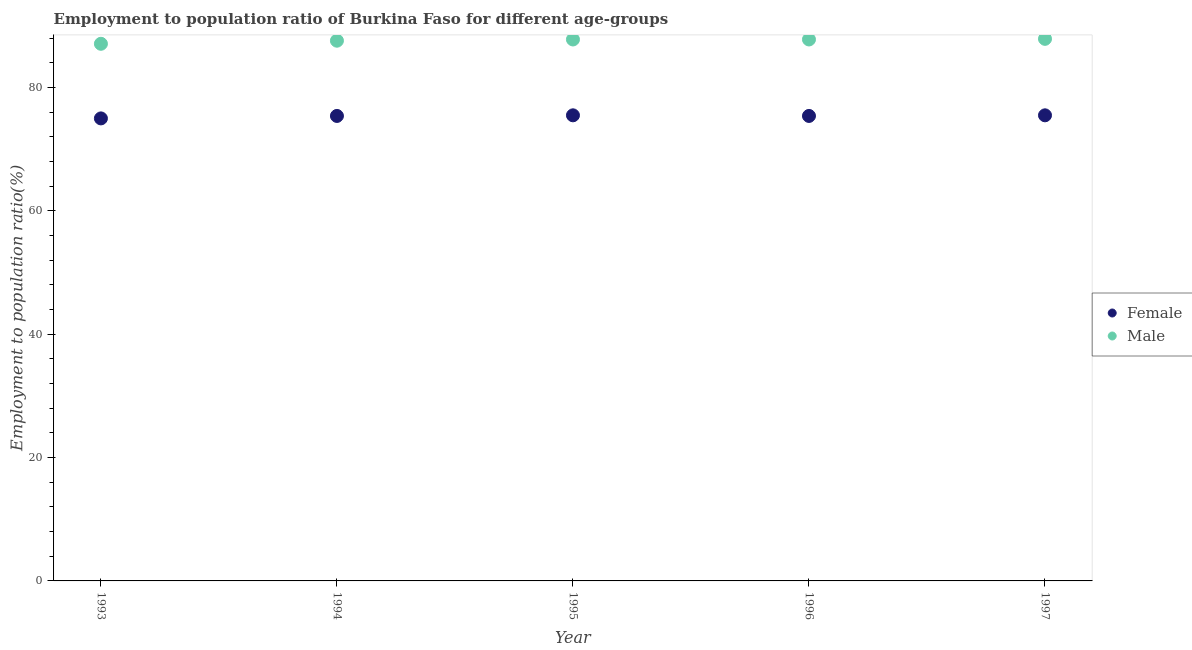Is the number of dotlines equal to the number of legend labels?
Your response must be concise. Yes. What is the employment to population ratio(male) in 1994?
Your answer should be compact. 87.6. Across all years, what is the maximum employment to population ratio(male)?
Your answer should be compact. 87.9. Across all years, what is the minimum employment to population ratio(female)?
Provide a succinct answer. 75. What is the total employment to population ratio(male) in the graph?
Keep it short and to the point. 438.2. What is the difference between the employment to population ratio(male) in 1994 and the employment to population ratio(female) in 1995?
Your answer should be very brief. 12.1. What is the average employment to population ratio(male) per year?
Keep it short and to the point. 87.64. In the year 1993, what is the difference between the employment to population ratio(female) and employment to population ratio(male)?
Keep it short and to the point. -12.1. What is the ratio of the employment to population ratio(female) in 1996 to that in 1997?
Provide a succinct answer. 1. What is the difference between the highest and the second highest employment to population ratio(female)?
Provide a succinct answer. 0. What is the difference between the highest and the lowest employment to population ratio(male)?
Provide a succinct answer. 0.8. In how many years, is the employment to population ratio(female) greater than the average employment to population ratio(female) taken over all years?
Ensure brevity in your answer.  4. Is the sum of the employment to population ratio(female) in 1996 and 1997 greater than the maximum employment to population ratio(male) across all years?
Ensure brevity in your answer.  Yes. Does the employment to population ratio(female) monotonically increase over the years?
Make the answer very short. No. What is the difference between two consecutive major ticks on the Y-axis?
Make the answer very short. 20. Are the values on the major ticks of Y-axis written in scientific E-notation?
Provide a short and direct response. No. Does the graph contain grids?
Make the answer very short. No. Where does the legend appear in the graph?
Your answer should be very brief. Center right. How are the legend labels stacked?
Ensure brevity in your answer.  Vertical. What is the title of the graph?
Offer a very short reply. Employment to population ratio of Burkina Faso for different age-groups. What is the label or title of the Y-axis?
Provide a short and direct response. Employment to population ratio(%). What is the Employment to population ratio(%) in Female in 1993?
Give a very brief answer. 75. What is the Employment to population ratio(%) in Male in 1993?
Your answer should be very brief. 87.1. What is the Employment to population ratio(%) in Female in 1994?
Provide a succinct answer. 75.4. What is the Employment to population ratio(%) in Male in 1994?
Offer a very short reply. 87.6. What is the Employment to population ratio(%) in Female in 1995?
Give a very brief answer. 75.5. What is the Employment to population ratio(%) in Male in 1995?
Make the answer very short. 87.8. What is the Employment to population ratio(%) in Female in 1996?
Give a very brief answer. 75.4. What is the Employment to population ratio(%) of Male in 1996?
Offer a very short reply. 87.8. What is the Employment to population ratio(%) of Female in 1997?
Offer a very short reply. 75.5. What is the Employment to population ratio(%) of Male in 1997?
Ensure brevity in your answer.  87.9. Across all years, what is the maximum Employment to population ratio(%) of Female?
Give a very brief answer. 75.5. Across all years, what is the maximum Employment to population ratio(%) in Male?
Your answer should be very brief. 87.9. Across all years, what is the minimum Employment to population ratio(%) of Female?
Your answer should be very brief. 75. Across all years, what is the minimum Employment to population ratio(%) of Male?
Your response must be concise. 87.1. What is the total Employment to population ratio(%) of Female in the graph?
Your answer should be compact. 376.8. What is the total Employment to population ratio(%) of Male in the graph?
Offer a very short reply. 438.2. What is the difference between the Employment to population ratio(%) of Male in 1993 and that in 1994?
Offer a terse response. -0.5. What is the difference between the Employment to population ratio(%) in Female in 1993 and that in 1996?
Your answer should be compact. -0.4. What is the difference between the Employment to population ratio(%) in Female in 1994 and that in 1995?
Your answer should be compact. -0.1. What is the difference between the Employment to population ratio(%) in Male in 1994 and that in 1995?
Provide a succinct answer. -0.2. What is the difference between the Employment to population ratio(%) in Female in 1994 and that in 1996?
Provide a short and direct response. 0. What is the difference between the Employment to population ratio(%) in Male in 1994 and that in 1997?
Your response must be concise. -0.3. What is the difference between the Employment to population ratio(%) in Female in 1995 and that in 1997?
Keep it short and to the point. 0. What is the difference between the Employment to population ratio(%) of Female in 1996 and that in 1997?
Give a very brief answer. -0.1. What is the difference between the Employment to population ratio(%) in Female in 1993 and the Employment to population ratio(%) in Male in 1994?
Provide a succinct answer. -12.6. What is the difference between the Employment to population ratio(%) in Female in 1993 and the Employment to population ratio(%) in Male in 1996?
Provide a succinct answer. -12.8. What is the difference between the Employment to population ratio(%) of Female in 1994 and the Employment to population ratio(%) of Male in 1995?
Offer a terse response. -12.4. What is the difference between the Employment to population ratio(%) of Female in 1994 and the Employment to population ratio(%) of Male in 1997?
Offer a very short reply. -12.5. What is the average Employment to population ratio(%) of Female per year?
Your answer should be very brief. 75.36. What is the average Employment to population ratio(%) of Male per year?
Provide a succinct answer. 87.64. In the year 1994, what is the difference between the Employment to population ratio(%) of Female and Employment to population ratio(%) of Male?
Your answer should be very brief. -12.2. In the year 1995, what is the difference between the Employment to population ratio(%) in Female and Employment to population ratio(%) in Male?
Keep it short and to the point. -12.3. In the year 1997, what is the difference between the Employment to population ratio(%) of Female and Employment to population ratio(%) of Male?
Offer a terse response. -12.4. What is the ratio of the Employment to population ratio(%) of Male in 1993 to that in 1994?
Provide a short and direct response. 0.99. What is the ratio of the Employment to population ratio(%) in Female in 1993 to that in 1995?
Make the answer very short. 0.99. What is the ratio of the Employment to population ratio(%) in Male in 1993 to that in 1995?
Keep it short and to the point. 0.99. What is the ratio of the Employment to population ratio(%) in Female in 1993 to that in 1997?
Your response must be concise. 0.99. What is the ratio of the Employment to population ratio(%) in Male in 1993 to that in 1997?
Provide a succinct answer. 0.99. What is the ratio of the Employment to population ratio(%) in Female in 1994 to that in 1995?
Your answer should be very brief. 1. What is the ratio of the Employment to population ratio(%) of Male in 1994 to that in 1995?
Provide a succinct answer. 1. What is the ratio of the Employment to population ratio(%) in Female in 1994 to that in 1996?
Ensure brevity in your answer.  1. What is the ratio of the Employment to population ratio(%) of Male in 1994 to that in 1996?
Give a very brief answer. 1. What is the ratio of the Employment to population ratio(%) in Female in 1995 to that in 1996?
Provide a short and direct response. 1. What is the ratio of the Employment to population ratio(%) of Male in 1995 to that in 1996?
Provide a short and direct response. 1. What is the ratio of the Employment to population ratio(%) of Male in 1996 to that in 1997?
Offer a terse response. 1. What is the difference between the highest and the second highest Employment to population ratio(%) in Female?
Offer a very short reply. 0. 